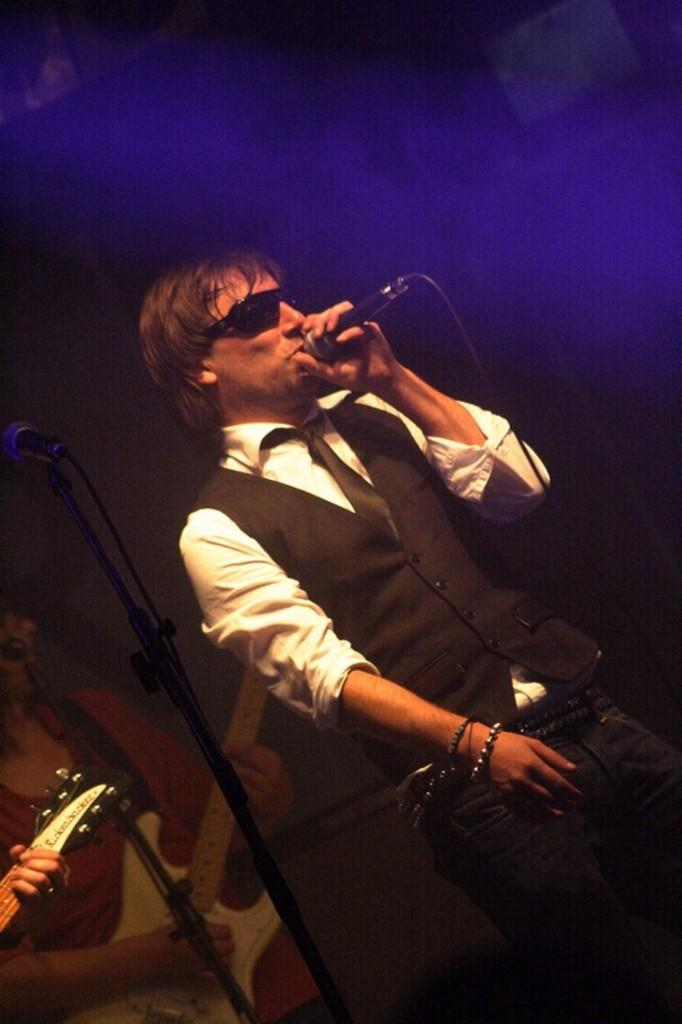What is the person on the mic doing in the image? The person on the mic is singing. What can be seen behind the person singing? There is a stand behind the person. What instrument is being played by another person in the image? There is a person holding a guitar. What type of key is hanging from the guitar in the image? There is no key visible on the guitar in the image. What is the secretary doing in the image? There is no secretary present in the image. 